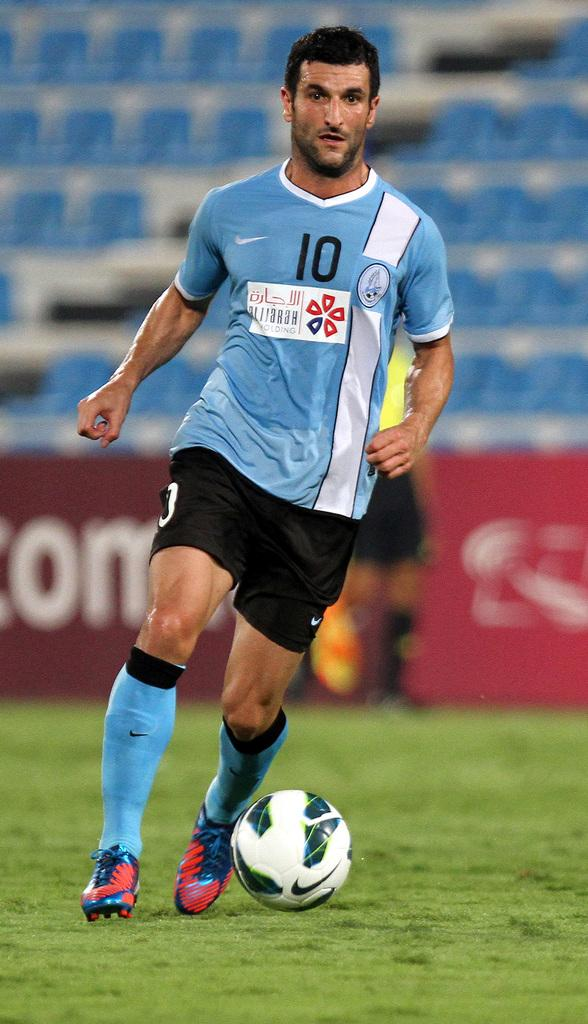<image>
Share a concise interpretation of the image provided. The soccer player in the number 10 uniform is in control of the ball. 